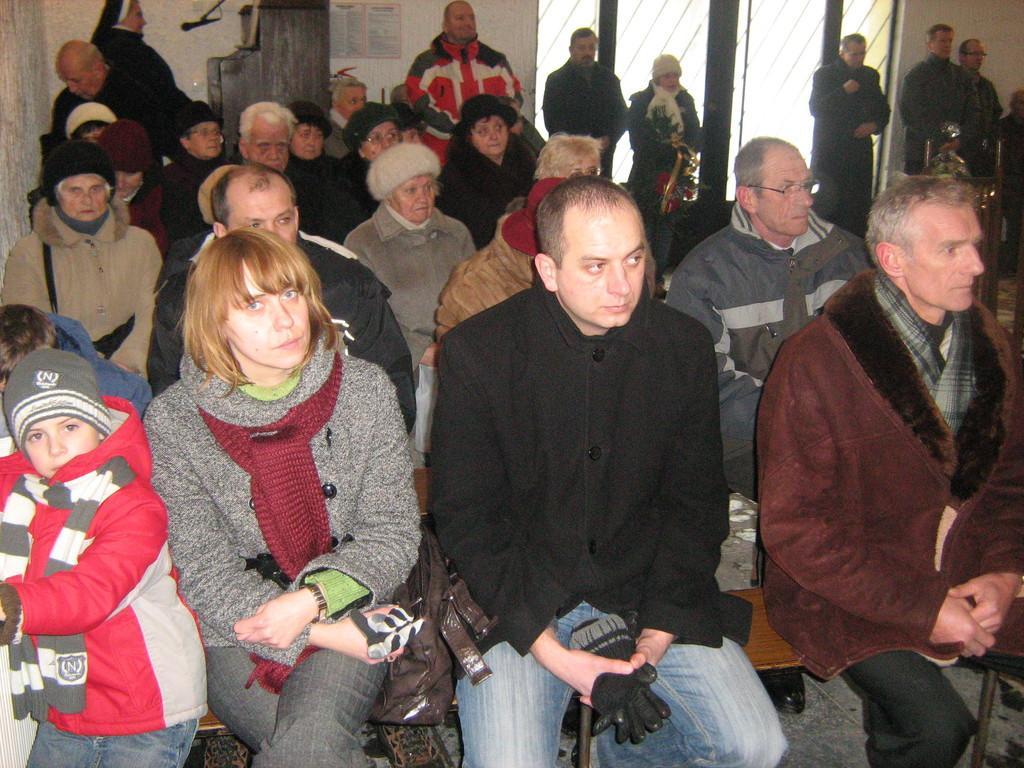Can you describe this image briefly? In this picture we can see group of people, few are sitting on the chairs and few are standing, in the background we can see a microphone and a poster on the wall. 